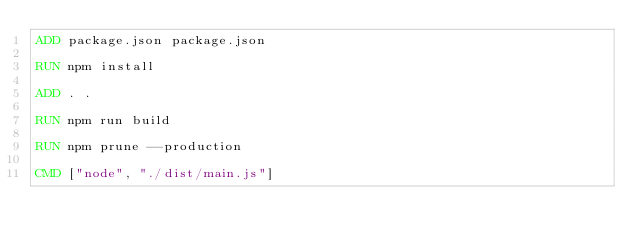<code> <loc_0><loc_0><loc_500><loc_500><_Dockerfile_>ADD package.json package.json

RUN npm install

ADD . .

RUN npm run build

RUN npm prune --production

CMD ["node", "./dist/main.js"]</code> 